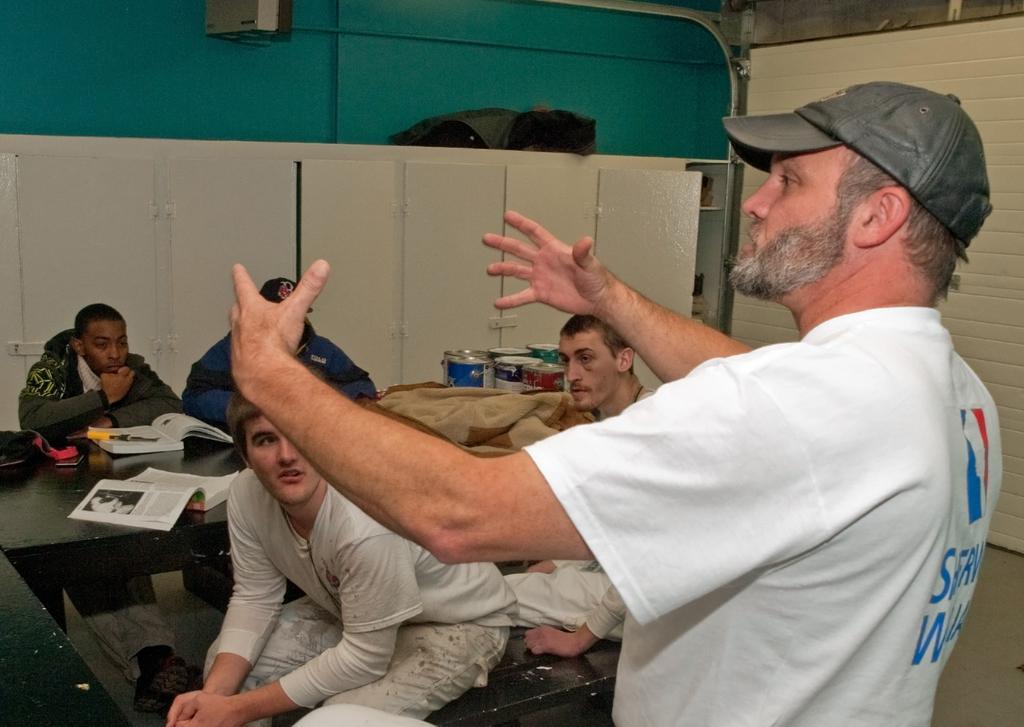Describe this image in one or two sentences. In this image I can see a four person sitting and one person is standing. I can see books and some objects on the table. Back I can see a boxes and a cream color cupboard. The wall is in peacock green color. 